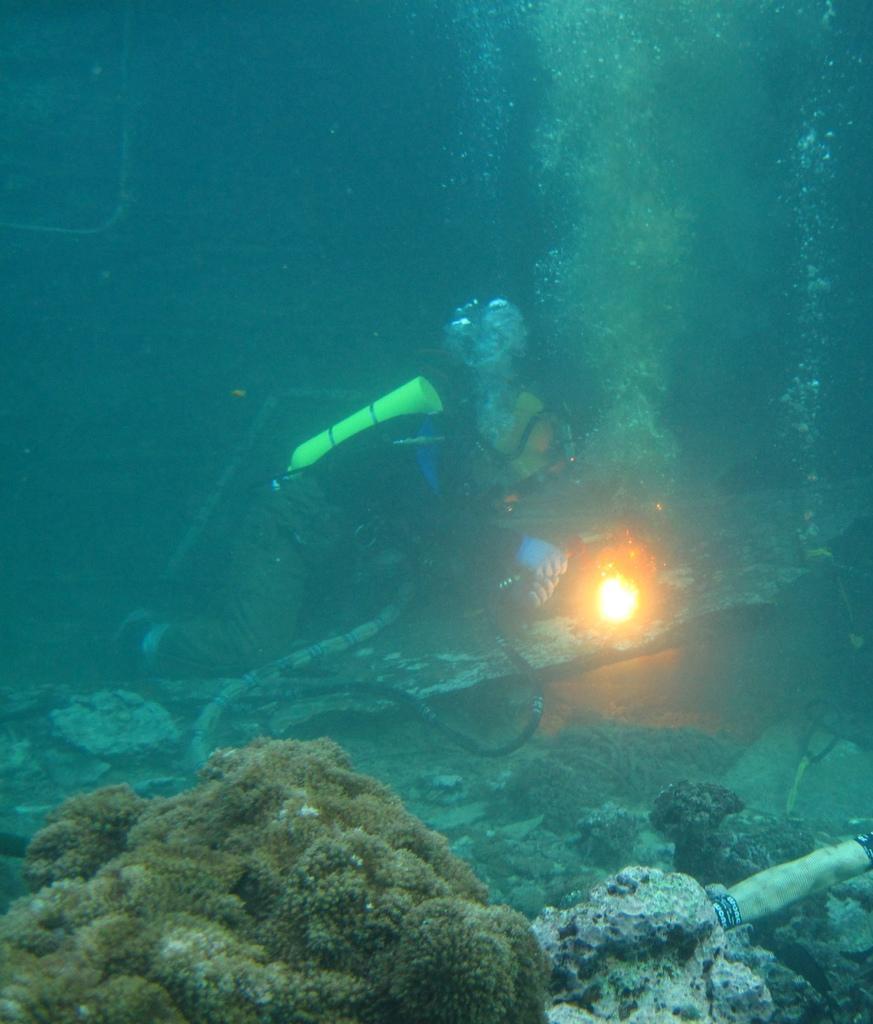How would you summarize this image in a sentence or two? The man in the middle of the picture wearing black jacket is scuba diving and beside him, we see rocks and aquatic plants. 